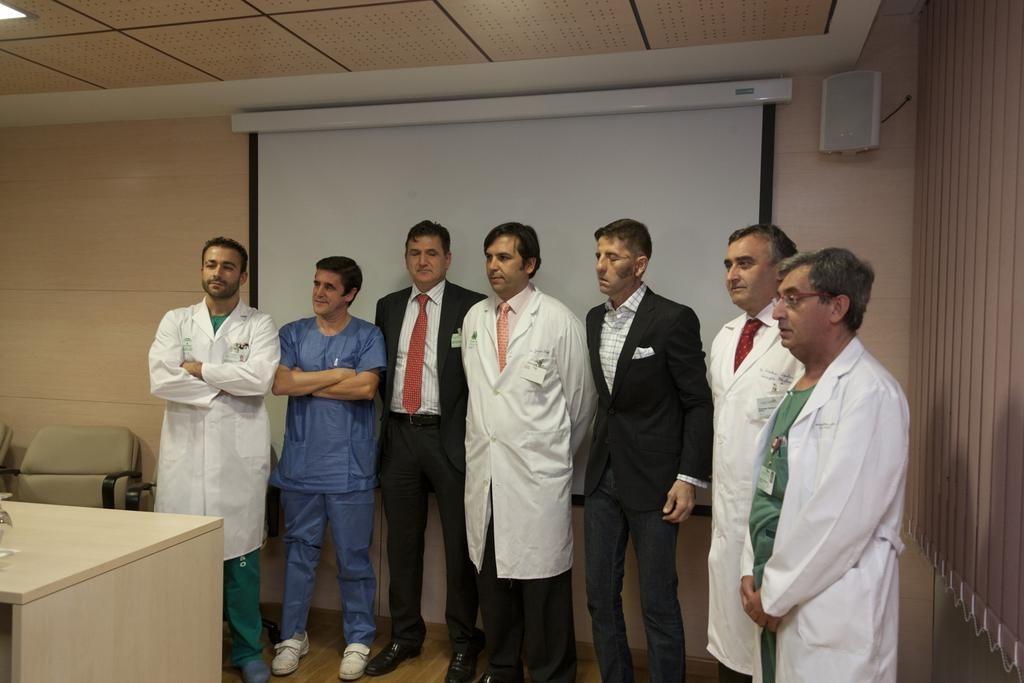What is the main subject of the image? There is a man standing in the middle of the image. What is the man wearing? The man is wearing a white coat. Are there any other people in the image? Yes, there are other people standing behind the man. What can be seen on the wall behind the people? There is a projector screen in the image. What type of jellyfish can be seen swimming on the projector screen in the image? There is no jellyfish present on the projector screen in the image. What taste sensation might the man be experiencing while wearing the white coat? There is no information about the man's taste sensations in the image. 